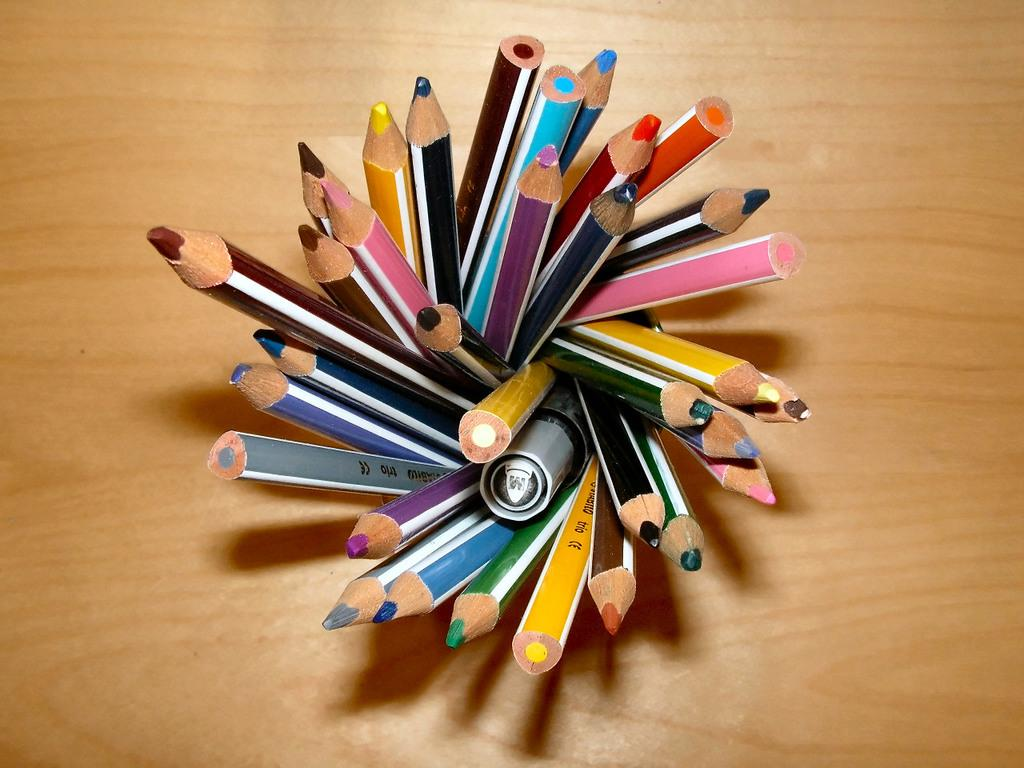What objects are present in the image? There are pencils in the image. Where are the pencils located? The pencils are on a wooden platform. Who is the creator of the pencils in the image? The image does not provide information about the creator of the pencils. 